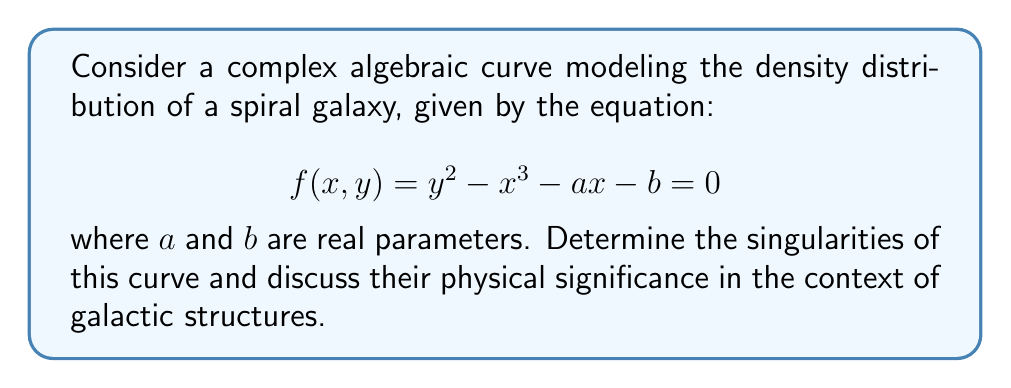Teach me how to tackle this problem. To find the singularities of the curve, we need to follow these steps:

1) Singularities occur at points where both partial derivatives of $f(x,y)$ are zero simultaneously with $f(x,y) = 0$. Let's compute the partial derivatives:

   $$\frac{\partial f}{\partial x} = -3x^2 - a$$
   $$\frac{\partial f}{\partial y} = 2y$$

2) Set both partial derivatives to zero:

   $-3x^2 - a = 0$ and $2y = 0$

3) Solve these equations:

   From $2y = 0$, we get $y = 0$.
   From $-3x^2 - a = 0$, we get $x = \pm \sqrt{-a/3}$ (only when $a \leq 0$).

4) Substitute these values back into the original equation:

   $f(x,0) = 0 - x^3 - ax - b = 0$
   $-x^3 - ax - b = 0$

5) For singularities to exist, this equation must be satisfied. Substituting $x = \pm \sqrt{-a/3}$:

   $-(\pm \sqrt{-a/3})^3 - a(\pm \sqrt{-a/3}) - b = 0$
   $\mp (-a/3)^{3/2} \pm a\sqrt{-a/3} - b = 0$
   $\pm 2(-a/3)^{3/2} - b = 0$
   $b = \pm 2(-a/3)^{3/2}$

6) Therefore, singularities exist when $a \leq 0$ and $b = \pm 2(-a/3)^{3/2}$. The singularities are located at the points $(\pm \sqrt{-a/3}, 0)$.

In the context of galactic structures, these singularities could represent regions of extreme density or gravitational influence, such as the galactic core or dense star-forming regions in spiral arms. The parameter $a$ might relate to the overall mass distribution, while $b$ could represent factors like angular momentum or external gravitational influences.
Answer: Singularities: $(\pm \sqrt{-a/3}, 0)$ when $a \leq 0$ and $b = \pm 2(-a/3)^{3/2}$ 